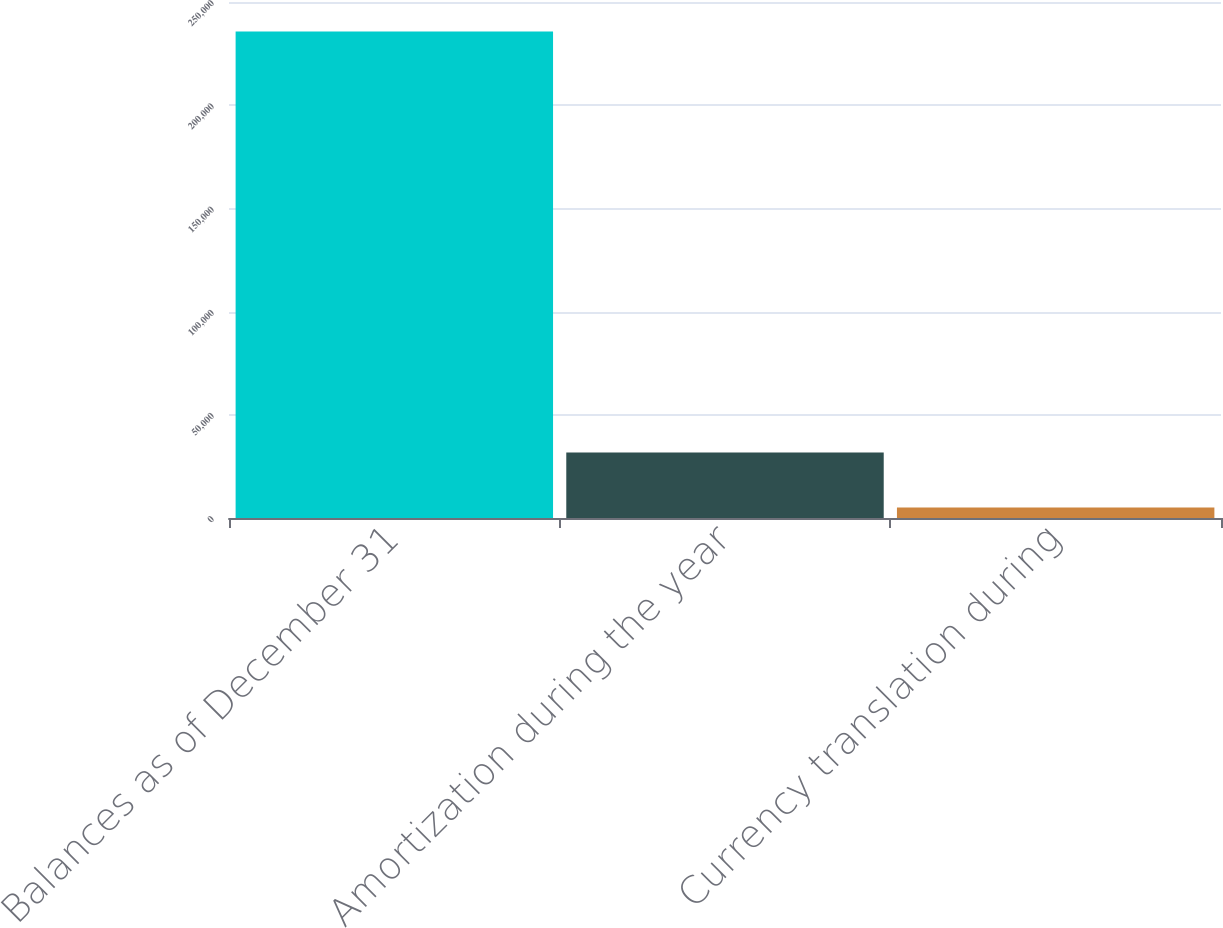Convert chart. <chart><loc_0><loc_0><loc_500><loc_500><bar_chart><fcel>Balances as of December 31<fcel>Amortization during the year<fcel>Currency translation during<nl><fcel>235704<fcel>31704.1<fcel>5102<nl></chart> 